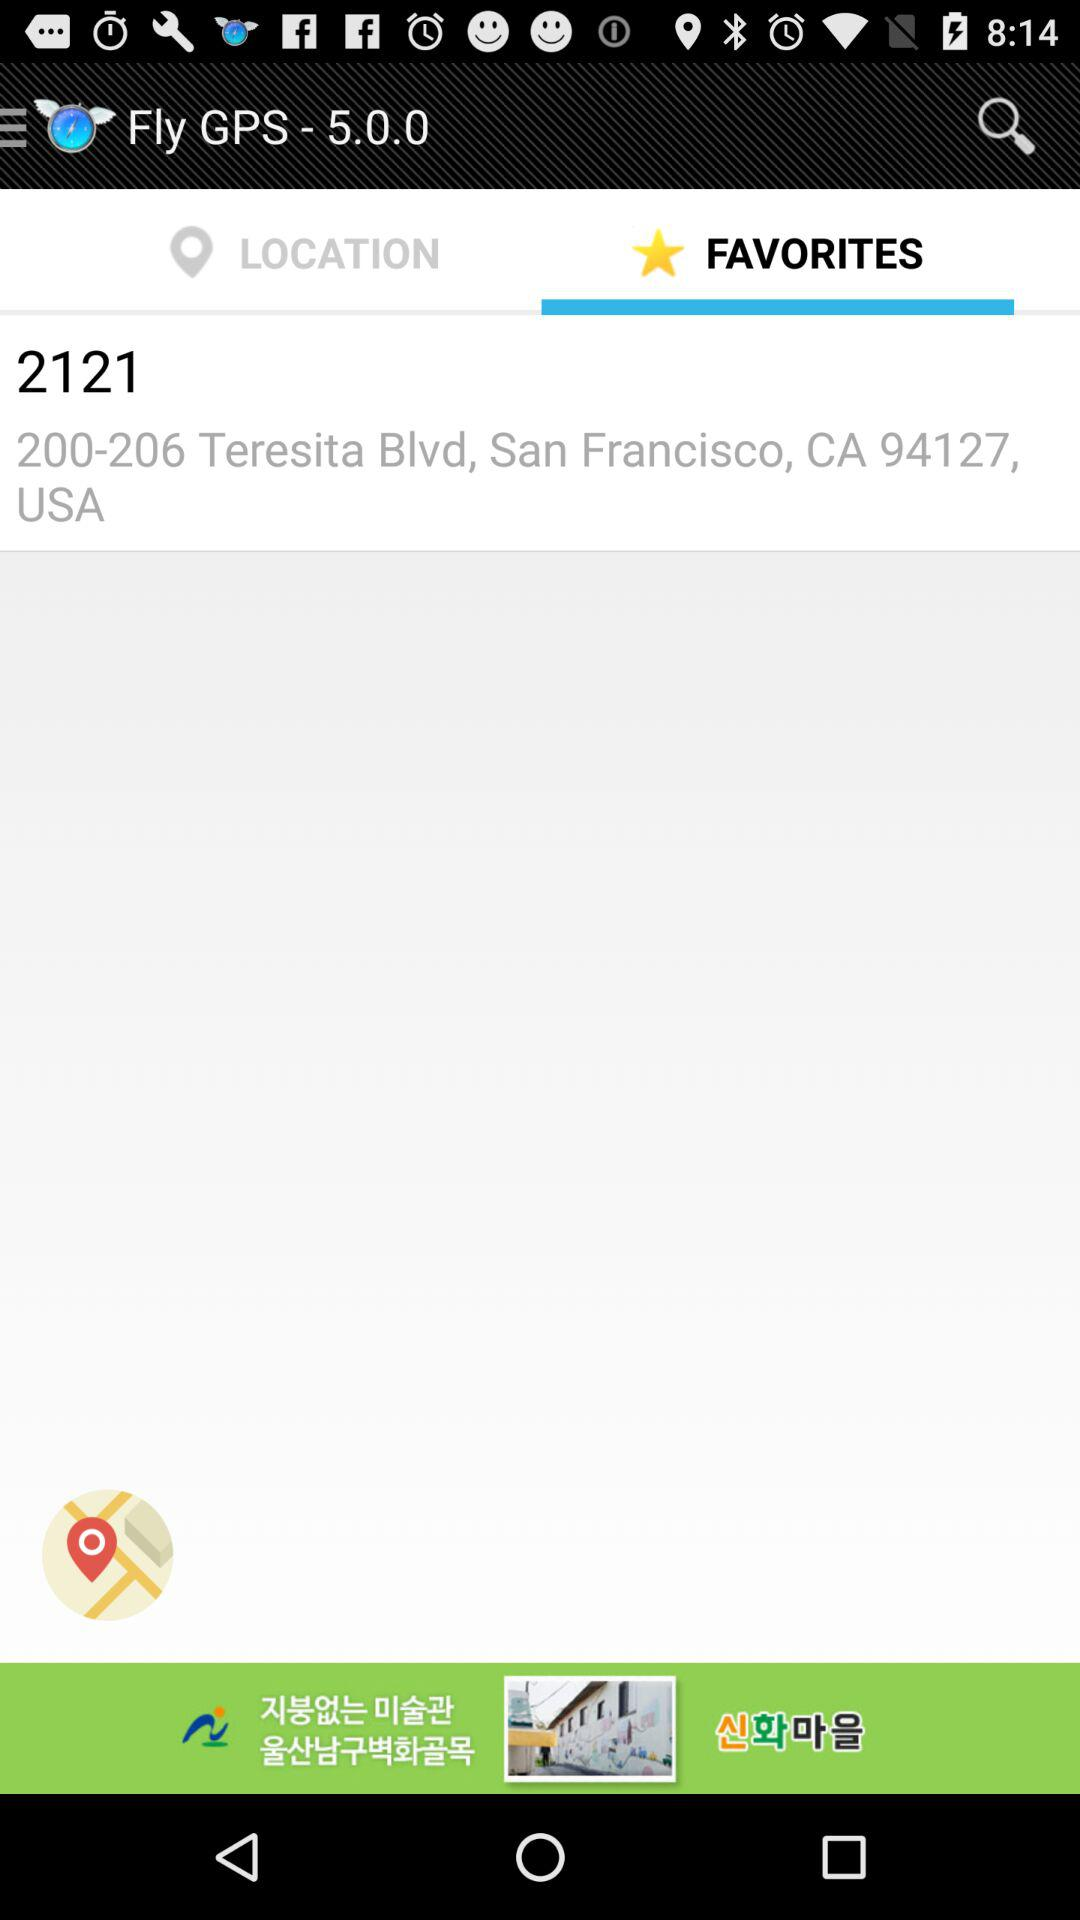What is the address shown on the screen? The address is 2121 200-206 Teresita Blvd, San Francisco, CA 94127, USA. 